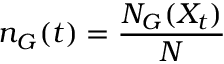Convert formula to latex. <formula><loc_0><loc_0><loc_500><loc_500>n _ { G } ( t ) = \frac { N _ { G } ( X _ { t } ) } { N }</formula> 